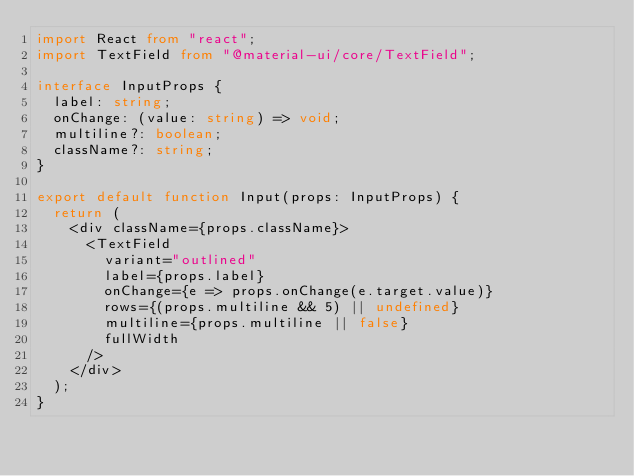<code> <loc_0><loc_0><loc_500><loc_500><_TypeScript_>import React from "react";
import TextField from "@material-ui/core/TextField";

interface InputProps {
  label: string;
  onChange: (value: string) => void;
  multiline?: boolean;
  className?: string;
}

export default function Input(props: InputProps) {
  return (
    <div className={props.className}>
      <TextField
        variant="outlined"
        label={props.label}
        onChange={e => props.onChange(e.target.value)}
        rows={(props.multiline && 5) || undefined}
        multiline={props.multiline || false}
        fullWidth
      />
    </div>
  );
}</code> 